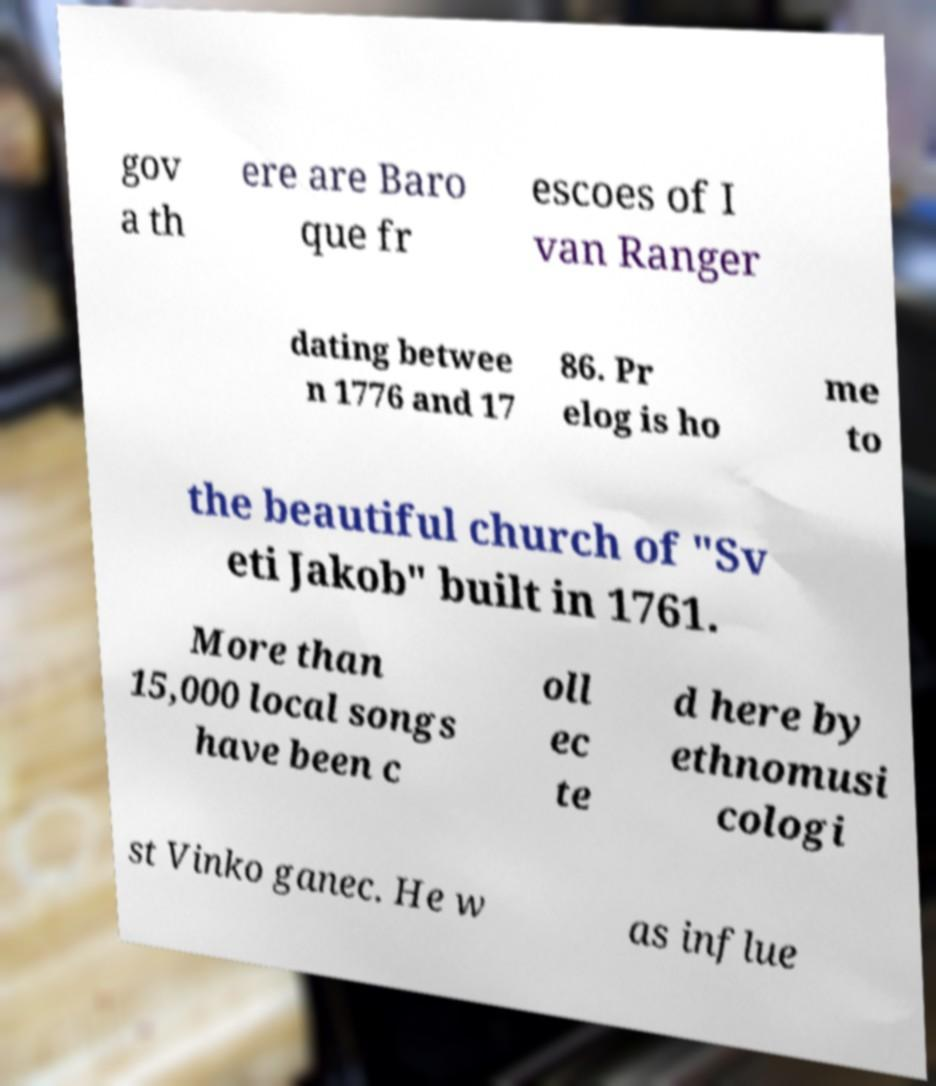Could you assist in decoding the text presented in this image and type it out clearly? gov a th ere are Baro que fr escoes of I van Ranger dating betwee n 1776 and 17 86. Pr elog is ho me to the beautiful church of "Sv eti Jakob" built in 1761. More than 15,000 local songs have been c oll ec te d here by ethnomusi cologi st Vinko ganec. He w as influe 